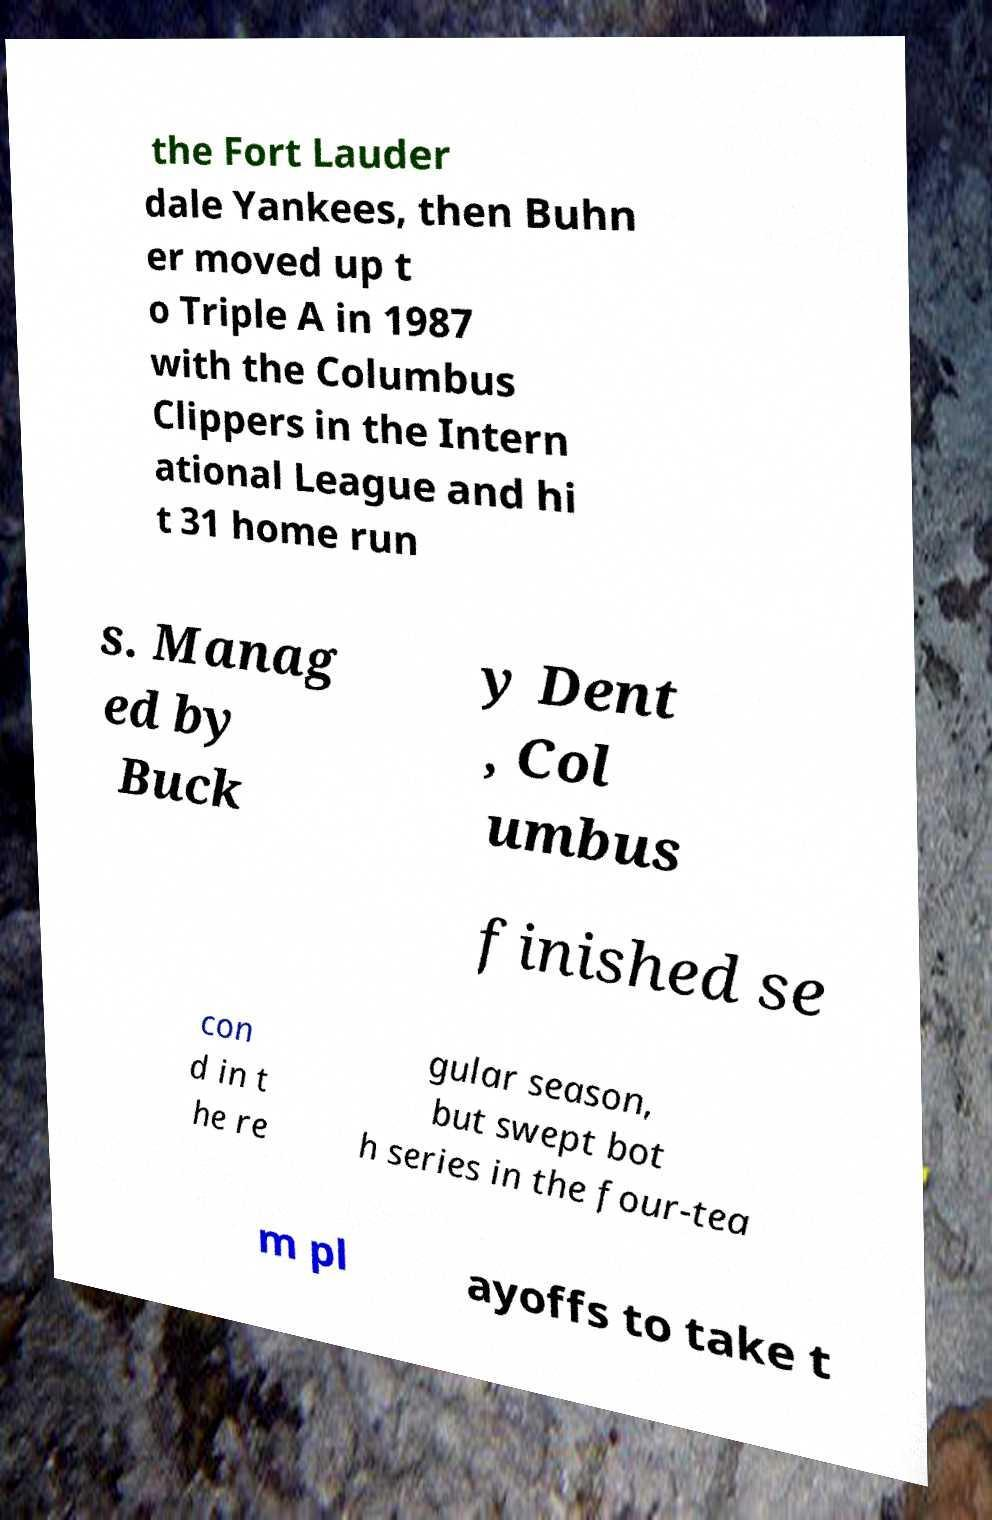Can you accurately transcribe the text from the provided image for me? the Fort Lauder dale Yankees, then Buhn er moved up t o Triple A in 1987 with the Columbus Clippers in the Intern ational League and hi t 31 home run s. Manag ed by Buck y Dent , Col umbus finished se con d in t he re gular season, but swept bot h series in the four-tea m pl ayoffs to take t 